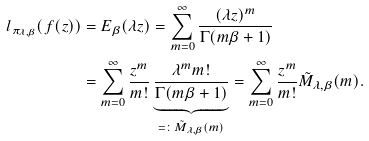Convert formula to latex. <formula><loc_0><loc_0><loc_500><loc_500>l _ { \pi _ { \lambda , \beta } } ( f ( z ) ) & = E _ { \beta } ( \lambda z ) = \sum _ { m = 0 } ^ { \infty } \frac { ( \lambda z ) ^ { m } } { \Gamma ( m \beta + 1 ) } \\ & = \sum _ { m = 0 } ^ { \infty } \frac { z ^ { m } } { m ! } \underbrace { \frac { \lambda ^ { m } m ! } { \Gamma ( m \beta + 1 ) } } _ { = \colon \tilde { M } _ { \lambda , \beta } ( m ) } = \sum _ { m = 0 } ^ { \infty } \frac { z ^ { m } } { m ! } \tilde { M } _ { \lambda , \beta } ( m ) .</formula> 